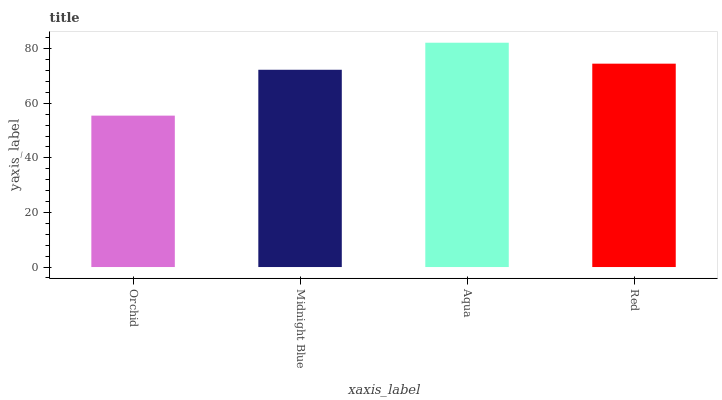Is Midnight Blue the minimum?
Answer yes or no. No. Is Midnight Blue the maximum?
Answer yes or no. No. Is Midnight Blue greater than Orchid?
Answer yes or no. Yes. Is Orchid less than Midnight Blue?
Answer yes or no. Yes. Is Orchid greater than Midnight Blue?
Answer yes or no. No. Is Midnight Blue less than Orchid?
Answer yes or no. No. Is Red the high median?
Answer yes or no. Yes. Is Midnight Blue the low median?
Answer yes or no. Yes. Is Orchid the high median?
Answer yes or no. No. Is Orchid the low median?
Answer yes or no. No. 